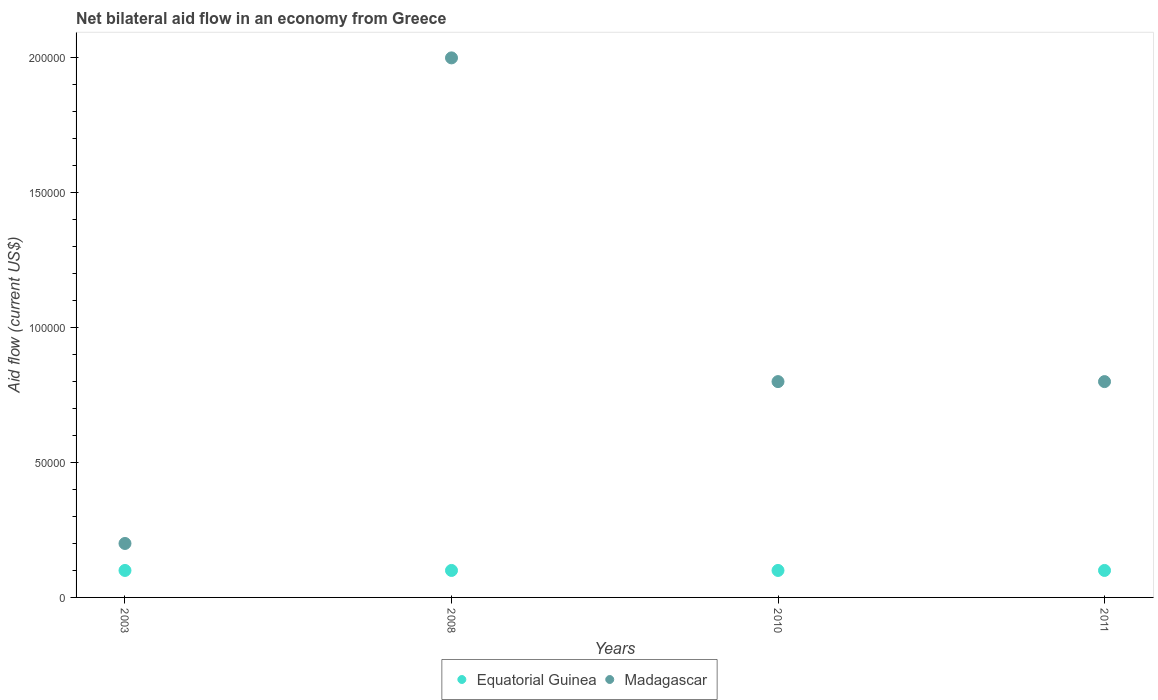Across all years, what is the maximum net bilateral aid flow in Equatorial Guinea?
Ensure brevity in your answer.  10000. Across all years, what is the minimum net bilateral aid flow in Equatorial Guinea?
Provide a succinct answer. 10000. What is the difference between the net bilateral aid flow in Madagascar in 2011 and the net bilateral aid flow in Equatorial Guinea in 2003?
Give a very brief answer. 7.00e+04. What is the average net bilateral aid flow in Madagascar per year?
Provide a succinct answer. 9.50e+04. In how many years, is the net bilateral aid flow in Equatorial Guinea greater than 190000 US$?
Make the answer very short. 0. Is the net bilateral aid flow in Equatorial Guinea in 2003 less than that in 2010?
Keep it short and to the point. No. What is the difference between the highest and the lowest net bilateral aid flow in Madagascar?
Keep it short and to the point. 1.80e+05. In how many years, is the net bilateral aid flow in Equatorial Guinea greater than the average net bilateral aid flow in Equatorial Guinea taken over all years?
Offer a terse response. 0. Is the sum of the net bilateral aid flow in Madagascar in 2010 and 2011 greater than the maximum net bilateral aid flow in Equatorial Guinea across all years?
Offer a very short reply. Yes. Does the net bilateral aid flow in Equatorial Guinea monotonically increase over the years?
Provide a succinct answer. No. Is the net bilateral aid flow in Equatorial Guinea strictly greater than the net bilateral aid flow in Madagascar over the years?
Give a very brief answer. No. Is the net bilateral aid flow in Madagascar strictly less than the net bilateral aid flow in Equatorial Guinea over the years?
Offer a terse response. No. How many legend labels are there?
Offer a very short reply. 2. How are the legend labels stacked?
Keep it short and to the point. Horizontal. What is the title of the graph?
Ensure brevity in your answer.  Net bilateral aid flow in an economy from Greece. Does "Iceland" appear as one of the legend labels in the graph?
Keep it short and to the point. No. What is the Aid flow (current US$) in Equatorial Guinea in 2003?
Offer a terse response. 10000. What is the Aid flow (current US$) of Madagascar in 2003?
Offer a very short reply. 2.00e+04. What is the Aid flow (current US$) in Equatorial Guinea in 2008?
Your answer should be compact. 10000. What is the Aid flow (current US$) in Madagascar in 2008?
Make the answer very short. 2.00e+05. What is the Aid flow (current US$) in Equatorial Guinea in 2010?
Your answer should be very brief. 10000. What is the Aid flow (current US$) in Madagascar in 2010?
Offer a terse response. 8.00e+04. What is the Aid flow (current US$) of Equatorial Guinea in 2011?
Keep it short and to the point. 10000. Across all years, what is the maximum Aid flow (current US$) in Equatorial Guinea?
Provide a succinct answer. 10000. Across all years, what is the minimum Aid flow (current US$) in Madagascar?
Give a very brief answer. 2.00e+04. What is the difference between the Aid flow (current US$) of Equatorial Guinea in 2003 and that in 2010?
Offer a very short reply. 0. What is the difference between the Aid flow (current US$) of Equatorial Guinea in 2003 and that in 2011?
Make the answer very short. 0. What is the difference between the Aid flow (current US$) of Madagascar in 2003 and that in 2011?
Give a very brief answer. -6.00e+04. What is the difference between the Aid flow (current US$) in Madagascar in 2008 and that in 2010?
Offer a terse response. 1.20e+05. What is the difference between the Aid flow (current US$) of Equatorial Guinea in 2008 and that in 2011?
Offer a very short reply. 0. What is the difference between the Aid flow (current US$) of Madagascar in 2008 and that in 2011?
Give a very brief answer. 1.20e+05. What is the difference between the Aid flow (current US$) of Equatorial Guinea in 2010 and that in 2011?
Ensure brevity in your answer.  0. What is the difference between the Aid flow (current US$) in Madagascar in 2010 and that in 2011?
Offer a terse response. 0. What is the difference between the Aid flow (current US$) in Equatorial Guinea in 2003 and the Aid flow (current US$) in Madagascar in 2008?
Offer a terse response. -1.90e+05. What is the difference between the Aid flow (current US$) in Equatorial Guinea in 2003 and the Aid flow (current US$) in Madagascar in 2010?
Provide a short and direct response. -7.00e+04. What is the difference between the Aid flow (current US$) of Equatorial Guinea in 2008 and the Aid flow (current US$) of Madagascar in 2011?
Your answer should be compact. -7.00e+04. What is the difference between the Aid flow (current US$) of Equatorial Guinea in 2010 and the Aid flow (current US$) of Madagascar in 2011?
Offer a terse response. -7.00e+04. What is the average Aid flow (current US$) of Equatorial Guinea per year?
Provide a short and direct response. 10000. What is the average Aid flow (current US$) of Madagascar per year?
Your response must be concise. 9.50e+04. In the year 2008, what is the difference between the Aid flow (current US$) in Equatorial Guinea and Aid flow (current US$) in Madagascar?
Ensure brevity in your answer.  -1.90e+05. What is the ratio of the Aid flow (current US$) in Madagascar in 2003 to that in 2008?
Keep it short and to the point. 0.1. What is the ratio of the Aid flow (current US$) of Madagascar in 2008 to that in 2010?
Your response must be concise. 2.5. What is the difference between the highest and the second highest Aid flow (current US$) of Madagascar?
Provide a short and direct response. 1.20e+05. 